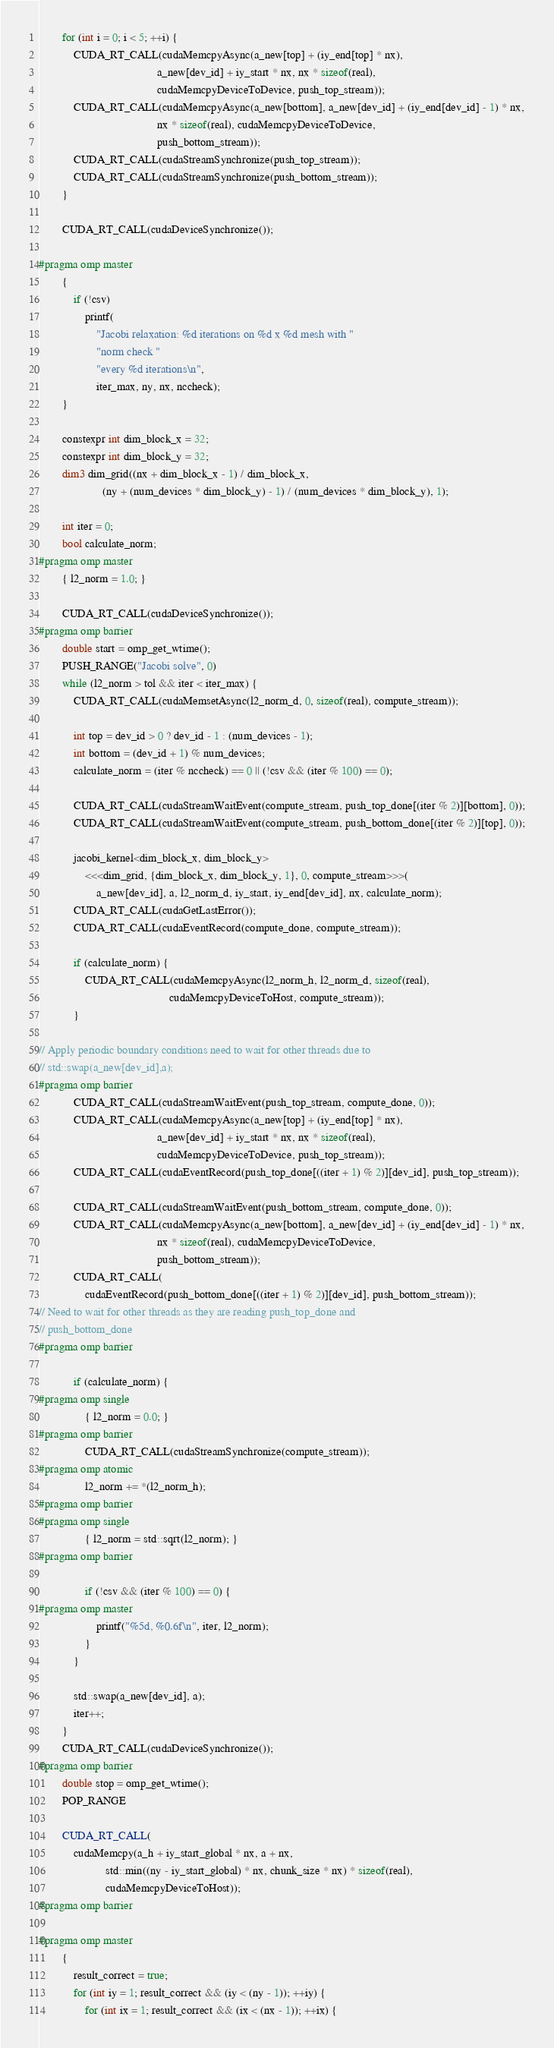<code> <loc_0><loc_0><loc_500><loc_500><_Cuda_>        for (int i = 0; i < 5; ++i) {
            CUDA_RT_CALL(cudaMemcpyAsync(a_new[top] + (iy_end[top] * nx),
                                         a_new[dev_id] + iy_start * nx, nx * sizeof(real),
                                         cudaMemcpyDeviceToDevice, push_top_stream));
            CUDA_RT_CALL(cudaMemcpyAsync(a_new[bottom], a_new[dev_id] + (iy_end[dev_id] - 1) * nx,
                                         nx * sizeof(real), cudaMemcpyDeviceToDevice,
                                         push_bottom_stream));
            CUDA_RT_CALL(cudaStreamSynchronize(push_top_stream));
            CUDA_RT_CALL(cudaStreamSynchronize(push_bottom_stream));
        }

        CUDA_RT_CALL(cudaDeviceSynchronize());

#pragma omp master
        {
            if (!csv)
                printf(
                    "Jacobi relaxation: %d iterations on %d x %d mesh with "
                    "norm check "
                    "every %d iterations\n",
                    iter_max, ny, nx, nccheck);
        }

        constexpr int dim_block_x = 32;
        constexpr int dim_block_y = 32;
        dim3 dim_grid((nx + dim_block_x - 1) / dim_block_x,
                      (ny + (num_devices * dim_block_y) - 1) / (num_devices * dim_block_y), 1);

        int iter = 0;
        bool calculate_norm;
#pragma omp master
        { l2_norm = 1.0; }

        CUDA_RT_CALL(cudaDeviceSynchronize());
#pragma omp barrier
        double start = omp_get_wtime();
        PUSH_RANGE("Jacobi solve", 0)
        while (l2_norm > tol && iter < iter_max) {
            CUDA_RT_CALL(cudaMemsetAsync(l2_norm_d, 0, sizeof(real), compute_stream));

            int top = dev_id > 0 ? dev_id - 1 : (num_devices - 1);
            int bottom = (dev_id + 1) % num_devices;
            calculate_norm = (iter % nccheck) == 0 || (!csv && (iter % 100) == 0);

            CUDA_RT_CALL(cudaStreamWaitEvent(compute_stream, push_top_done[(iter % 2)][bottom], 0));
            CUDA_RT_CALL(cudaStreamWaitEvent(compute_stream, push_bottom_done[(iter % 2)][top], 0));

            jacobi_kernel<dim_block_x, dim_block_y>
                <<<dim_grid, {dim_block_x, dim_block_y, 1}, 0, compute_stream>>>(
                    a_new[dev_id], a, l2_norm_d, iy_start, iy_end[dev_id], nx, calculate_norm);
            CUDA_RT_CALL(cudaGetLastError());
            CUDA_RT_CALL(cudaEventRecord(compute_done, compute_stream));

            if (calculate_norm) {
                CUDA_RT_CALL(cudaMemcpyAsync(l2_norm_h, l2_norm_d, sizeof(real),
                                             cudaMemcpyDeviceToHost, compute_stream));
            }

// Apply periodic boundary conditions need to wait for other threads due to
// std::swap(a_new[dev_id],a);
#pragma omp barrier
            CUDA_RT_CALL(cudaStreamWaitEvent(push_top_stream, compute_done, 0));
            CUDA_RT_CALL(cudaMemcpyAsync(a_new[top] + (iy_end[top] * nx),
                                         a_new[dev_id] + iy_start * nx, nx * sizeof(real),
                                         cudaMemcpyDeviceToDevice, push_top_stream));
            CUDA_RT_CALL(cudaEventRecord(push_top_done[((iter + 1) % 2)][dev_id], push_top_stream));

            CUDA_RT_CALL(cudaStreamWaitEvent(push_bottom_stream, compute_done, 0));
            CUDA_RT_CALL(cudaMemcpyAsync(a_new[bottom], a_new[dev_id] + (iy_end[dev_id] - 1) * nx,
                                         nx * sizeof(real), cudaMemcpyDeviceToDevice,
                                         push_bottom_stream));
            CUDA_RT_CALL(
                cudaEventRecord(push_bottom_done[((iter + 1) % 2)][dev_id], push_bottom_stream));
// Need to wait for other threads as they are reading push_top_done and
// push_bottom_done
#pragma omp barrier

            if (calculate_norm) {
#pragma omp single
                { l2_norm = 0.0; }
#pragma omp barrier
                CUDA_RT_CALL(cudaStreamSynchronize(compute_stream));
#pragma omp atomic
                l2_norm += *(l2_norm_h);
#pragma omp barrier
#pragma omp single
                { l2_norm = std::sqrt(l2_norm); }
#pragma omp barrier

                if (!csv && (iter % 100) == 0) {
#pragma omp master
                    printf("%5d, %0.6f\n", iter, l2_norm);
                }
            }

            std::swap(a_new[dev_id], a);
            iter++;
        }
        CUDA_RT_CALL(cudaDeviceSynchronize());
#pragma omp barrier
        double stop = omp_get_wtime();
        POP_RANGE

        CUDA_RT_CALL(
            cudaMemcpy(a_h + iy_start_global * nx, a + nx,
                       std::min((ny - iy_start_global) * nx, chunk_size * nx) * sizeof(real),
                       cudaMemcpyDeviceToHost));
#pragma omp barrier

#pragma omp master
        {
            result_correct = true;
            for (int iy = 1; result_correct && (iy < (ny - 1)); ++iy) {
                for (int ix = 1; result_correct && (ix < (nx - 1)); ++ix) {</code> 